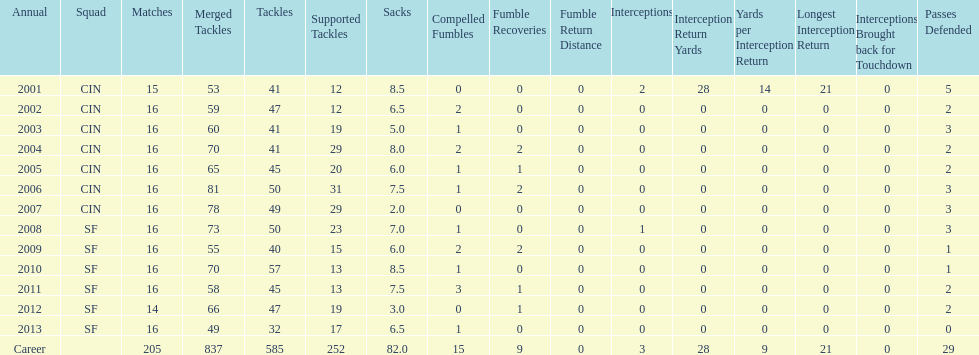What is the total number of sacks smith has made? 82.0. 